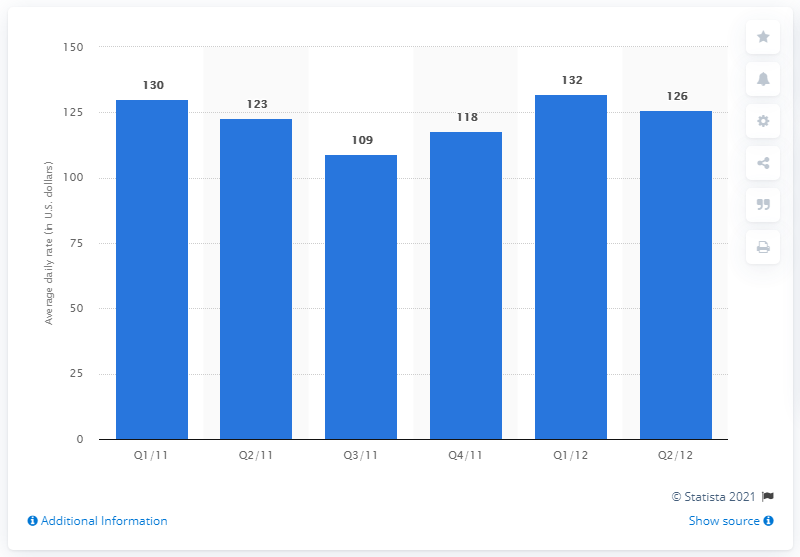Outline some significant characteristics in this image. The average daily rate in Orlando during the third quarter of 2011 was approximately $109. 